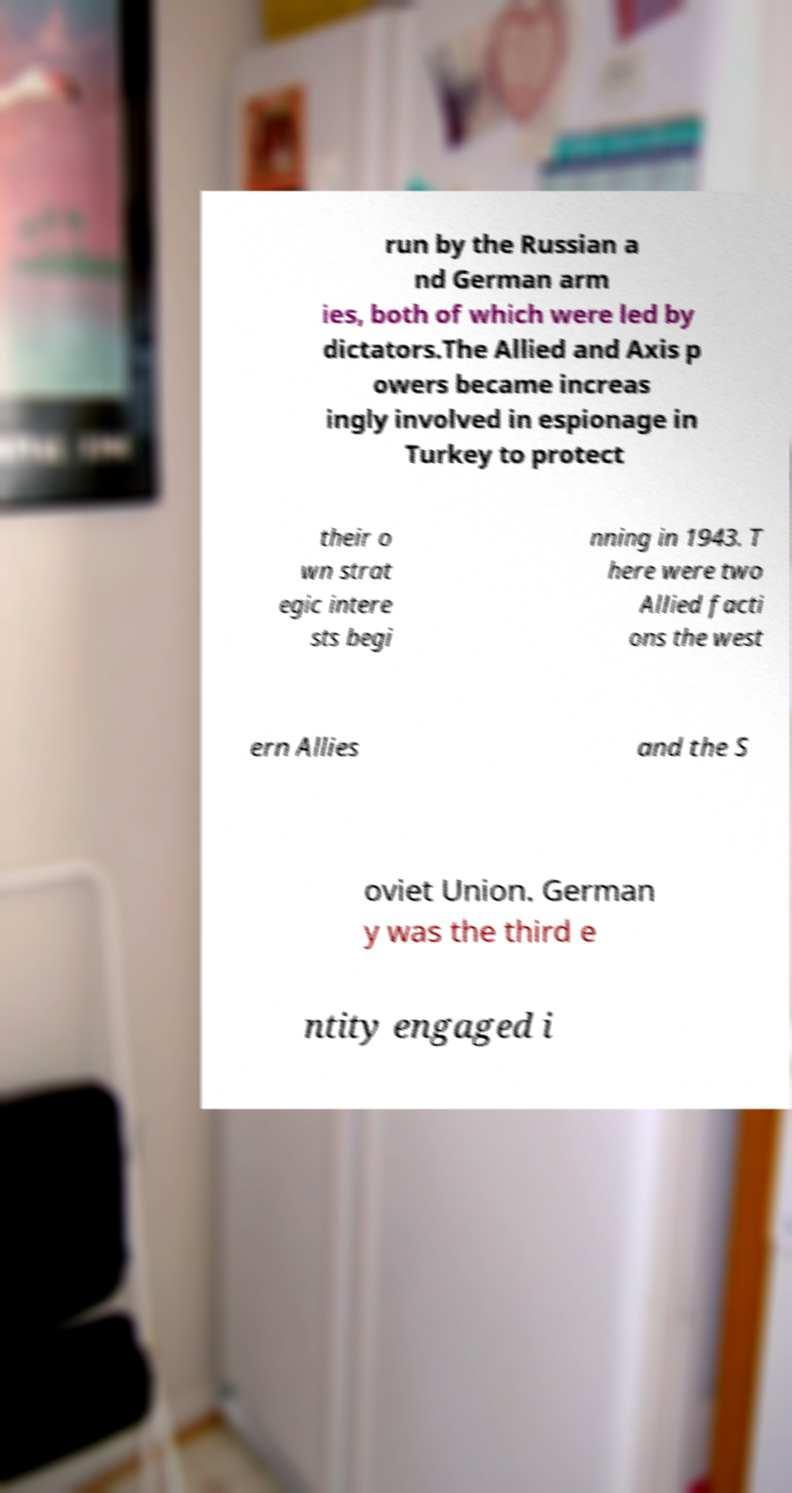Could you extract and type out the text from this image? run by the Russian a nd German arm ies, both of which were led by dictators.The Allied and Axis p owers became increas ingly involved in espionage in Turkey to protect their o wn strat egic intere sts begi nning in 1943. T here were two Allied facti ons the west ern Allies and the S oviet Union. German y was the third e ntity engaged i 